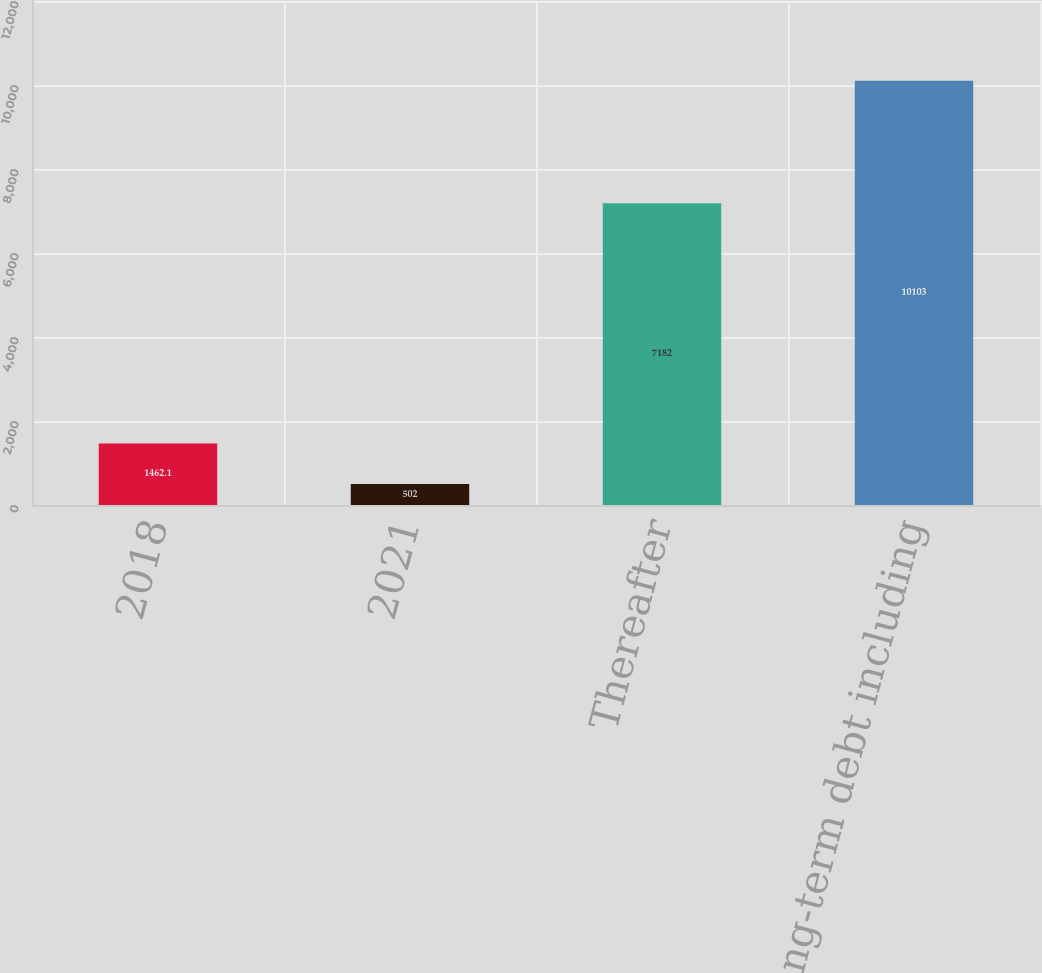<chart> <loc_0><loc_0><loc_500><loc_500><bar_chart><fcel>2018<fcel>2021<fcel>Thereafter<fcel>Total long-term debt including<nl><fcel>1462.1<fcel>502<fcel>7182<fcel>10103<nl></chart> 